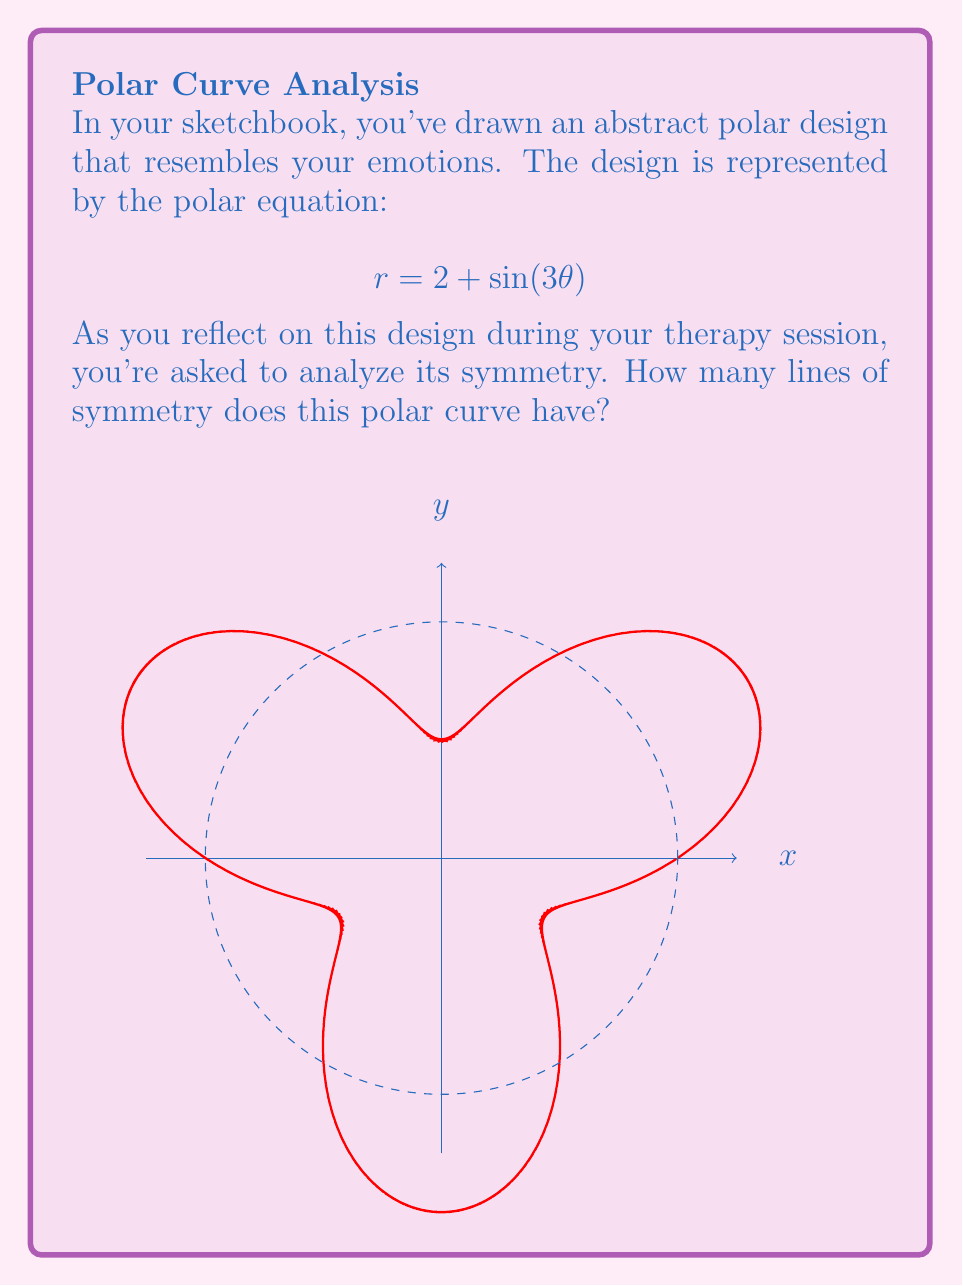Can you answer this question? Let's approach this step-by-step:

1) First, recall that for a polar curve $r = f(\theta)$, lines of symmetry occur when the curve repeats itself either through reflection or rotation.

2) The function $\sin(3\theta)$ has a period of $\frac{2\pi}{3}$. This means the curve repeats every $\frac{2\pi}{3}$ radians, or 120°.

3) To find lines of symmetry, we need to consider both reflective and rotational symmetry:

   a) Reflective symmetry occurs when $f(\theta) = f(-\theta)$. In this case:
      $2 + \sin(3\theta) = 2 + \sin(-3\theta)$
      This is true because sine is an odd function, so $\sin(-3\theta) = -\sin(3\theta)$.

   b) Rotational symmetry occurs at multiples of $\frac{2\pi}{3}$ due to the period of $\sin(3\theta)$.

4) The curve has reflective symmetry along the x-axis ($\theta = 0$) due to the property of sine functions.

5) It also has rotational symmetry at $\frac{2\pi}{3}$ and $\frac{4\pi}{3}$, which correspond to 120° and 240° rotations.

6) Each of these rotational symmetries also creates a line of reflective symmetry.

7) Therefore, the curve has 3 lines of symmetry: one along the x-axis, and two more at 60° and 120° from the x-axis (or 30° and 90° from the y-axis).

This threefold symmetry might represent the complex, yet balanced nature of your emotions as expressed in your sketch.
Answer: 3 lines of symmetry 